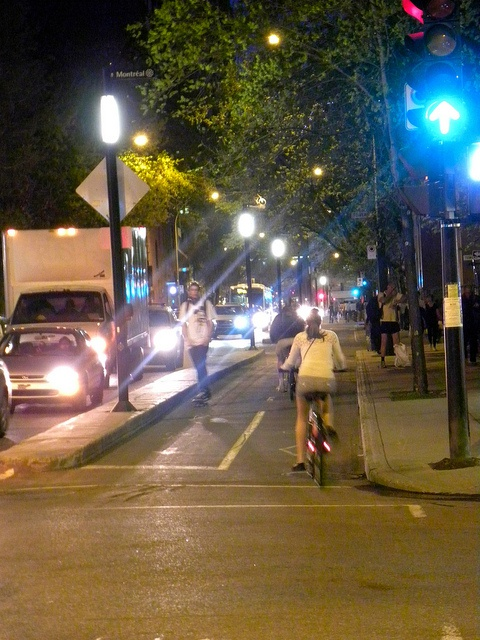Describe the objects in this image and their specific colors. I can see truck in black, tan, gray, and darkgray tones, car in black, brown, white, lightpink, and darkgray tones, traffic light in black, cyan, lightblue, and white tones, truck in black, maroon, gray, and brown tones, and people in black, tan, gray, and olive tones in this image. 